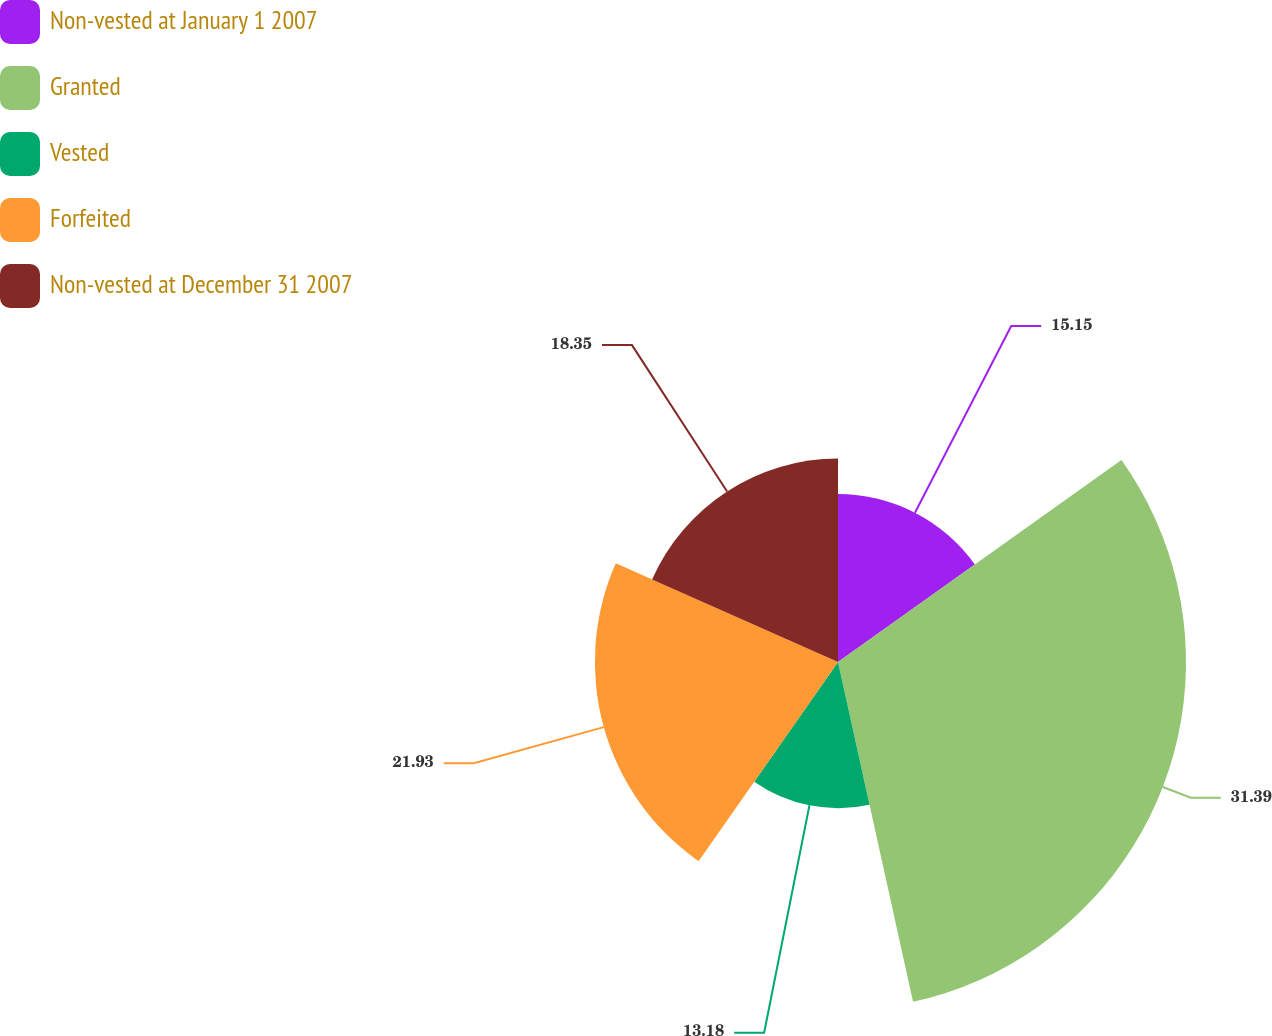Convert chart. <chart><loc_0><loc_0><loc_500><loc_500><pie_chart><fcel>Non-vested at January 1 2007<fcel>Granted<fcel>Vested<fcel>Forfeited<fcel>Non-vested at December 31 2007<nl><fcel>15.15%<fcel>31.39%<fcel>13.18%<fcel>21.93%<fcel>18.35%<nl></chart> 